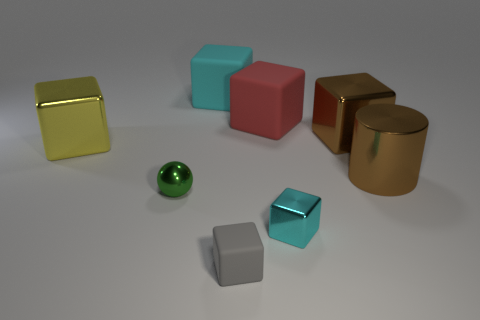There is a red matte thing that is the same size as the cylinder; what shape is it? The red object you're referring to is a cube. Like the cylinder, it has clearly defined edges and flat faces, distinguishing it as a cube, which is a six-faced three-dimensional shape with each face in the form of a square. 